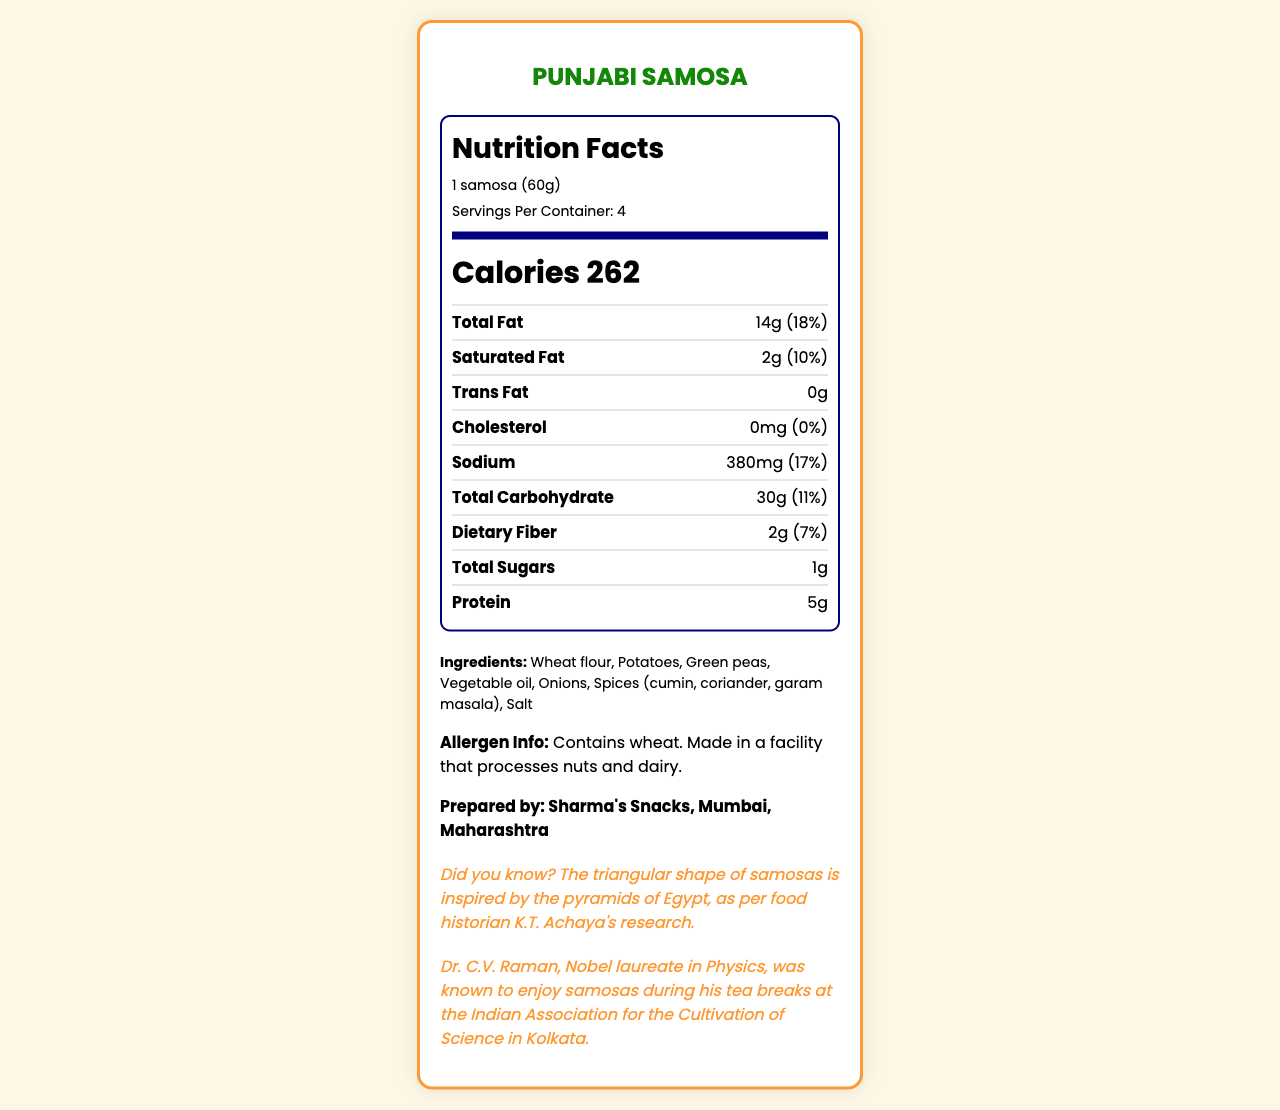what is the total number of calories per serving? The document specifies that each serving size (1 samosa) contains 262 calories.
Answer: 262 calories how much saturated fat does a serving of samosa contain? The document mentions that each serving has 2g of saturated fat.
Answer: 2g what is the percent daily value of total fat per serving? The document indicates that the total fat per serving is 14g, with a percent daily value of 18%.
Answer: 18% how many servings are in one container of samosas? The document states that there are 4 servings per container.
Answer: 4 what is the amount of sodium per serving? The document lists the sodium content per serving as 380mg.
Answer: 380mg which of the following nutrients is not present in the samosa? A. Cholesterol B. Dietary Fiber C. Trans Fat The document shows that the cholesterol content is 0mg, which means there is no cholesterol.
Answer: A. Cholesterol the total carbohydrate in one serving is: A. 20g B. 30g C. 40g D. 50g The document states that the total carbohydrate amount per serving is 30g.
Answer: B. 30g the percentage daily value of dietary fiber per serving is: i. 5% ii. 7% iii. 10% iv. 15% The document mentions that the dietary fiber per serving is 2g and its percent daily value is 7%.
Answer: ii. 7% does the samosa contain any added sugars? The document shows the amount of added sugars as 0g, indicating there are no added sugars.
Answer: No was Dr. C.V. Raman associated with samosas in any way? The document mentions that Dr. C.V. Raman enjoyed samosas during his tea breaks at the Indian Association for the Cultivation of Science in Kolkata.
Answer: Yes summarize the main nutritional components and additional information provided in the document. The document includes a detailed nutritional breakdown per serving and total servings per container. It lists each nutrient's amount and percent daily value, ingredients, allergen information, and fun facts.
Answer: The document provides nutritional information for Punjabi Samosas, including details on serving size, calories, fat content, and other nutrients. It also lists ingredients and allergen info. Additionally, it includes a fun fact about the origin of samosas' shape and a connection to Dr. C.V. Raman. who conducted the study linking the triangular shape of samosas to the pyramids of Egypt? The document mentions the finding without specifying who conducted the study.
Answer: Not enough information how much vitamin D is present in one serving of the samosa? The document specifies that the vitamin D content per serving is 0mcg.
Answer: 0mcg how much protein does one samosa contain? The document states that each samosa contains 5g of protein.
Answer: 5g what percentage of daily calcium does one serving provide? The document indicates that one serving provides 2% of the daily value for calcium.
Answer: 2% 